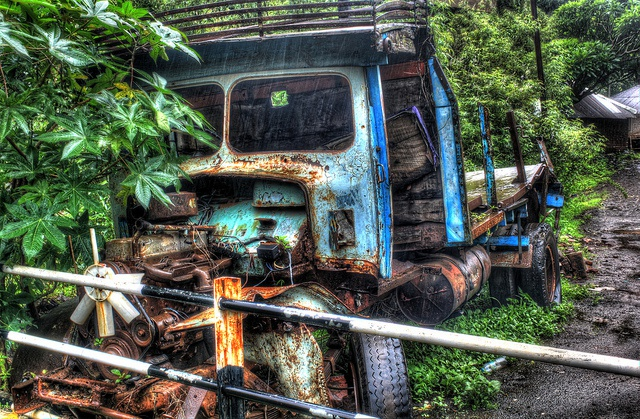Describe the objects in this image and their specific colors. I can see a truck in green, black, gray, white, and maroon tones in this image. 